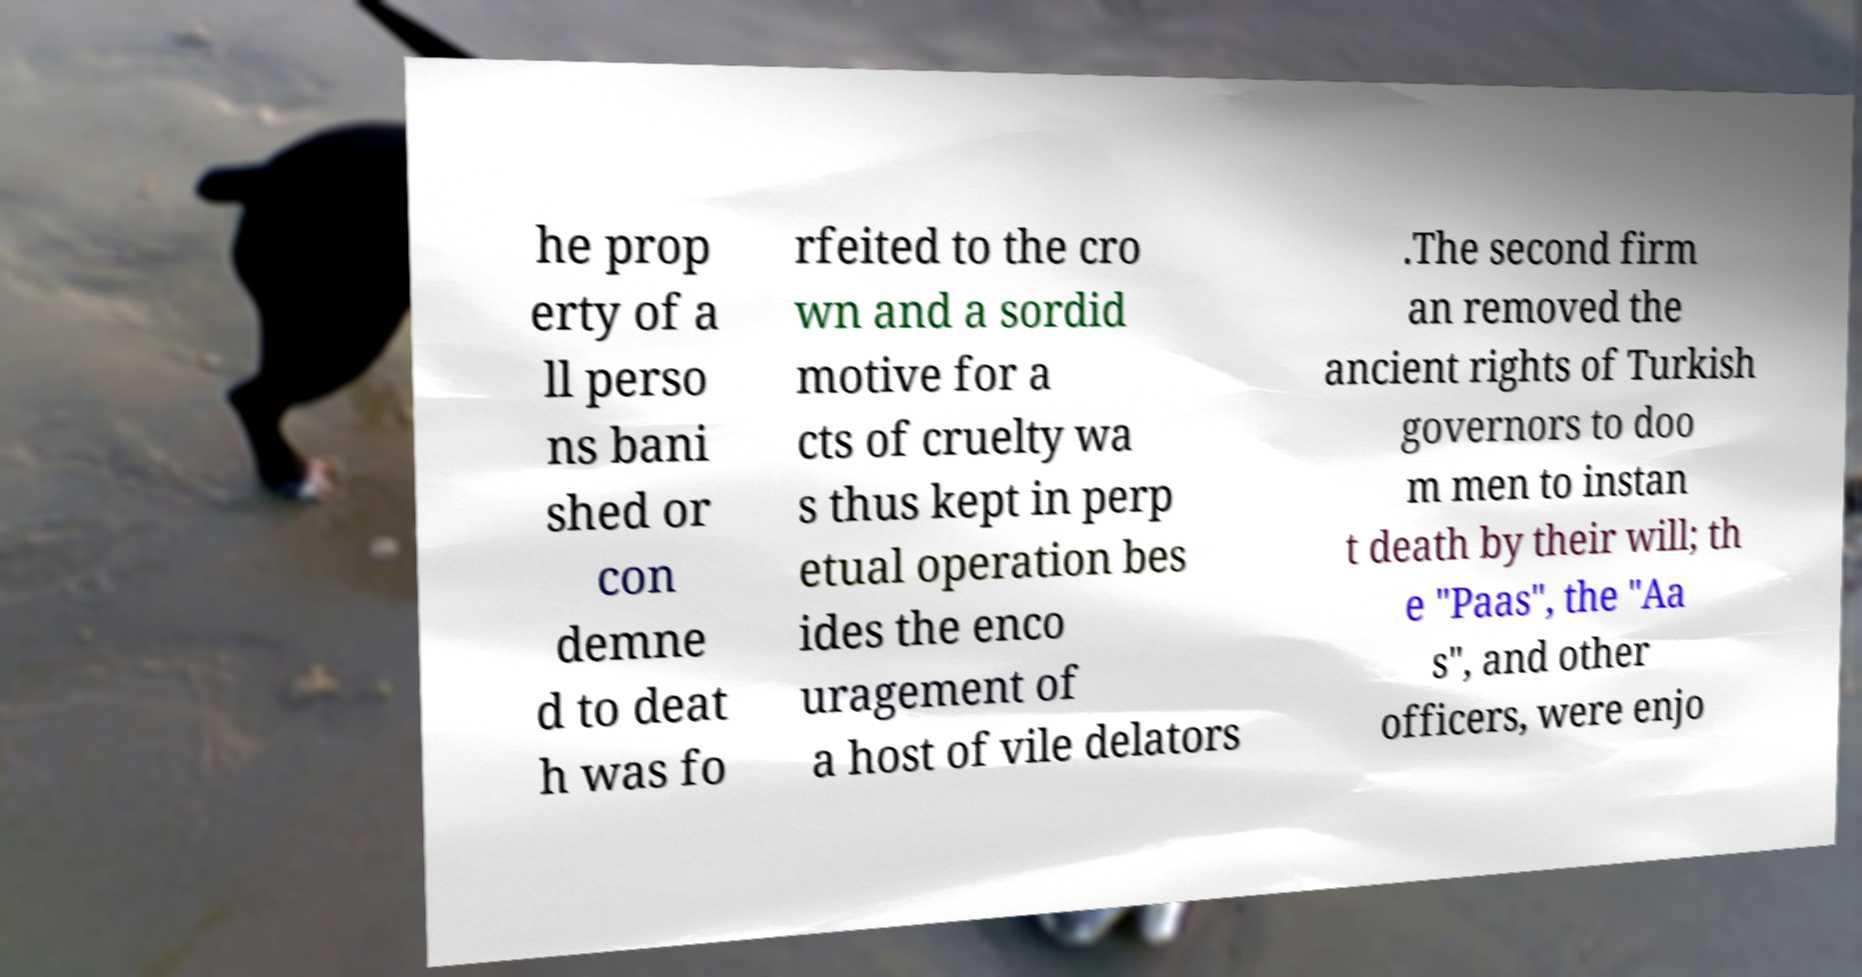Could you assist in decoding the text presented in this image and type it out clearly? he prop erty of a ll perso ns bani shed or con demne d to deat h was fo rfeited to the cro wn and a sordid motive for a cts of cruelty wa s thus kept in perp etual operation bes ides the enco uragement of a host of vile delators .The second firm an removed the ancient rights of Turkish governors to doo m men to instan t death by their will; th e "Paas", the "Aa s", and other officers, were enjo 